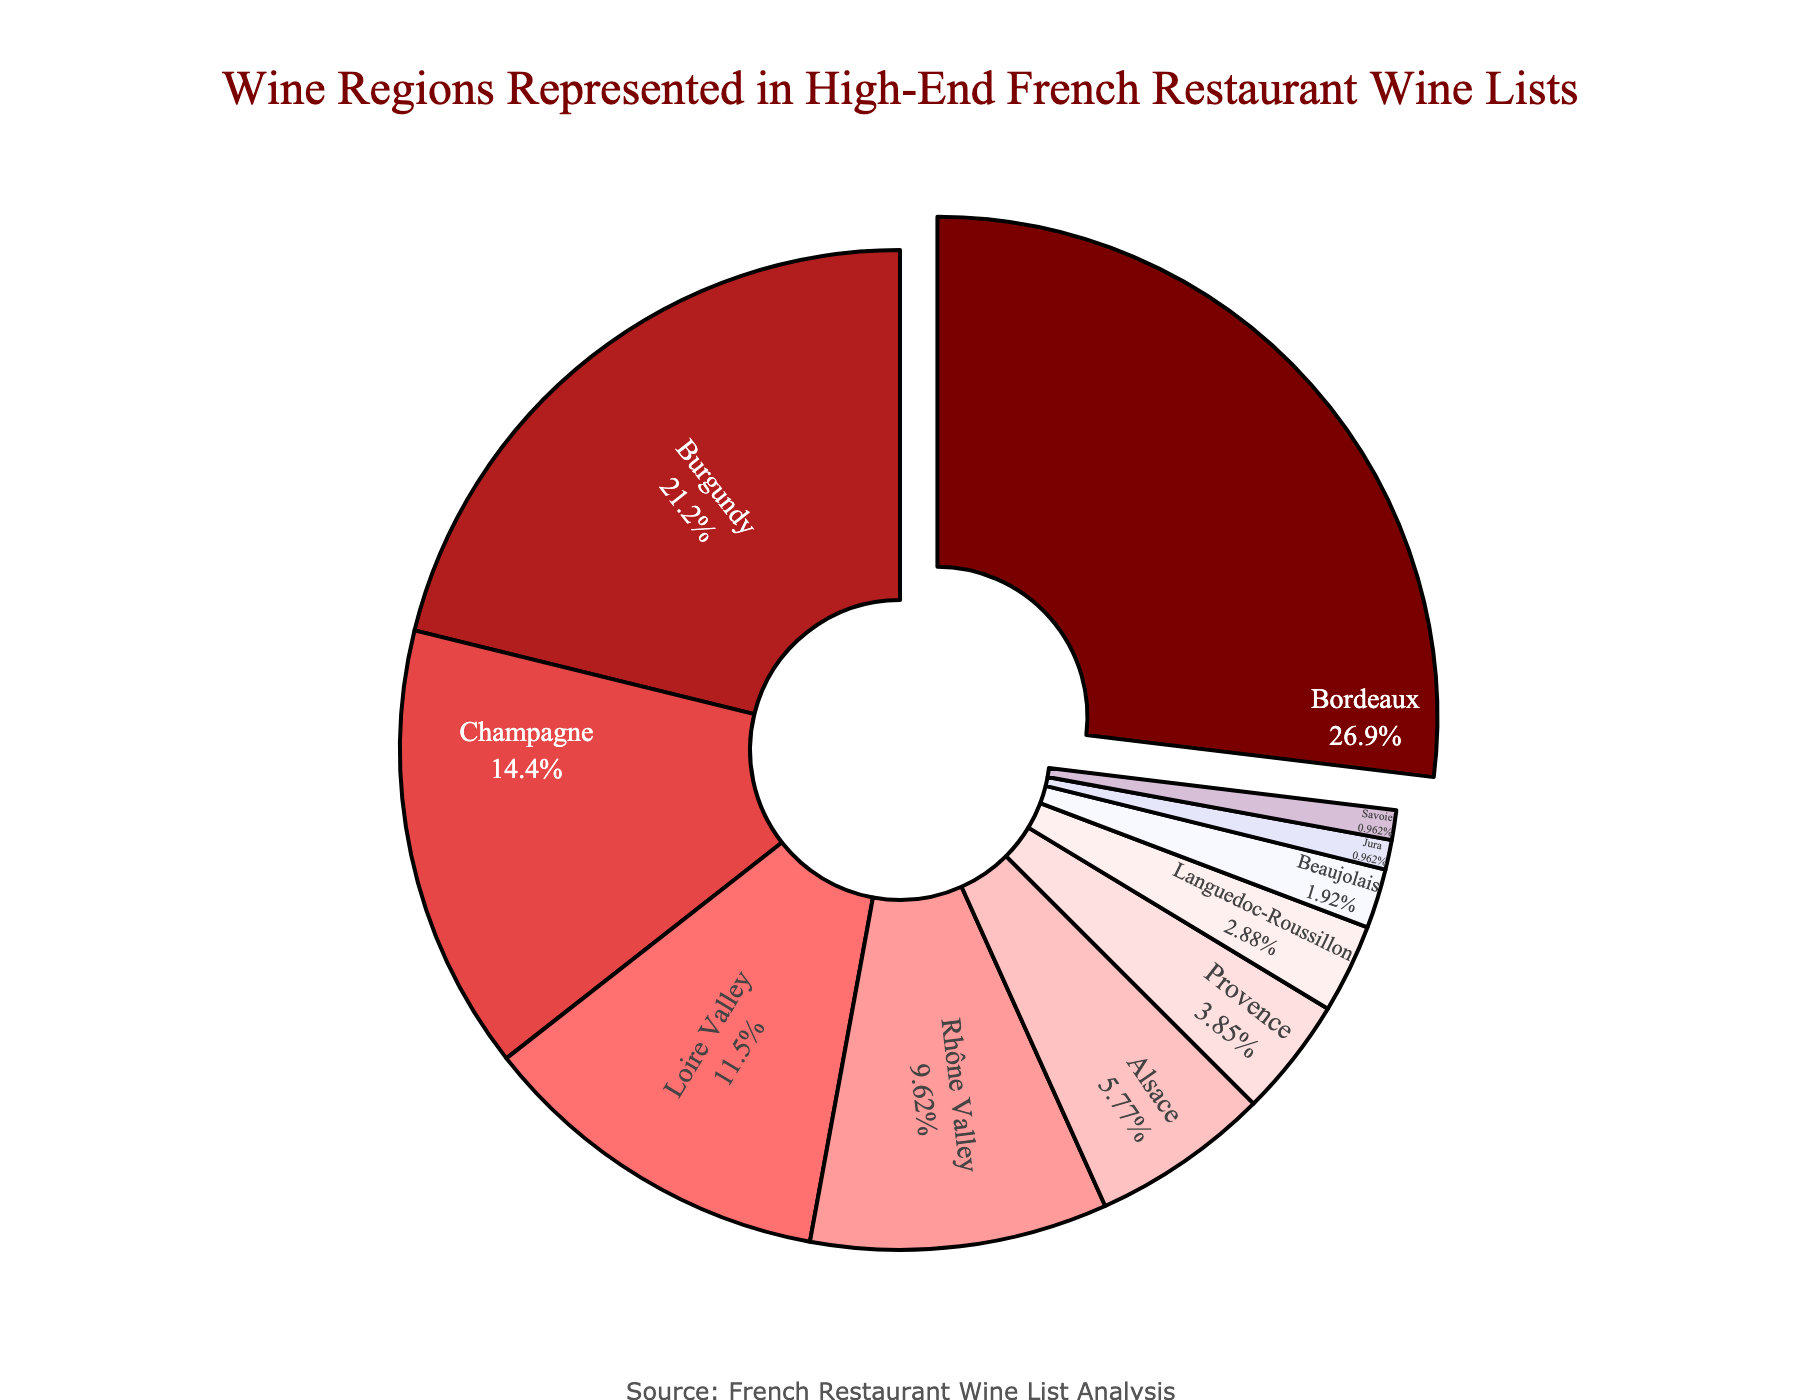what percentage of the wine list is represented by Bordeaux and Burgundy combined? To find the combined percentage of the wine list represented by Bordeaux and Burgundy, add the two percentages together: 28% (Bordeaux) + 22% (Burgundy) = 50%.
Answer: 50% how much more prevalent is Bordeaux compared to Rhône Valley in the wine list? To find how much more prevalent Bordeaux is compared to Rhône Valley, subtract the percentage of Rhône Valley from the percentage of Bordeaux: 28% (Bordeaux) - 10% (Rhône Valley) = 18%.
Answer: 18% which region has the smallest representation on the wine list? By looking at the pie chart, Jura and Savoie each represent the smallest percentage of 1%.
Answer: Jura and Savoie which regions combined constitute at least half of the wine list? To determine which regions combined constitute at least half (50%) of the wine list, add the highest percentages until the sum is equal to or greater than 50%. Bordeaux (28%) + Burgundy (22%) = 50%.
Answer: Bordeaux and Burgundy among Champagne, Alsace, and Provence, which region has the highest representation? Compare the percentages of Champagne (15%), Alsace (6%), and Provence (4%). Champagne has the highest representation among these regions.
Answer: Champagne how do the combined percentages of Loire Valley and Champagne compare to the percentage of Bordeaux alone? Add the percentages of Loire Valley and Champagne: 12% (Loire Valley) + 15% (Champagne) = 27%. Bordeaux is 28%. Compare 27% to 28%.
Answer: Bordeaux is 1% higher which region is represented with a pink color? By examining the legend or visual cues of the pie chart, the pink color corresponds to Provence.
Answer: Provence calculate the average representation of regions with more than 10% in the wine list Identify regions with more than 10% (Bordeaux, Burgundy, Champagne, and Loire Valley). Sum their percentages: 28% + 22% + 15% + 12% = 77%. Divide by 4 (number of regions): 77% / 4 = 19.25%.
Answer: 19.25% which region has a representation twice that of Alsace? Alsace has a representation of 6%. The region with twice this representation is Burgundy, which has 12% (2 * 6 = 12).
Answer: Burgundy 